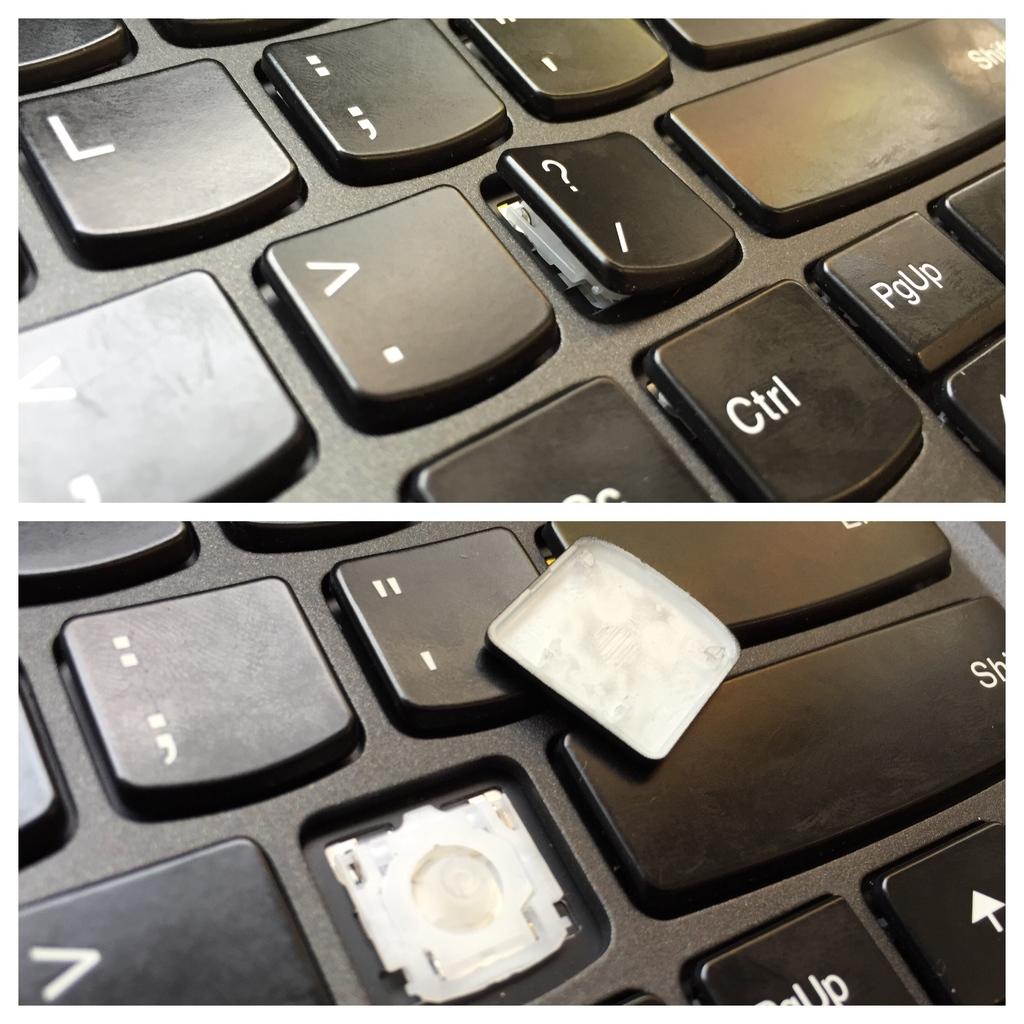Which key is removed form the keyboard?
Keep it short and to the point. ?. 